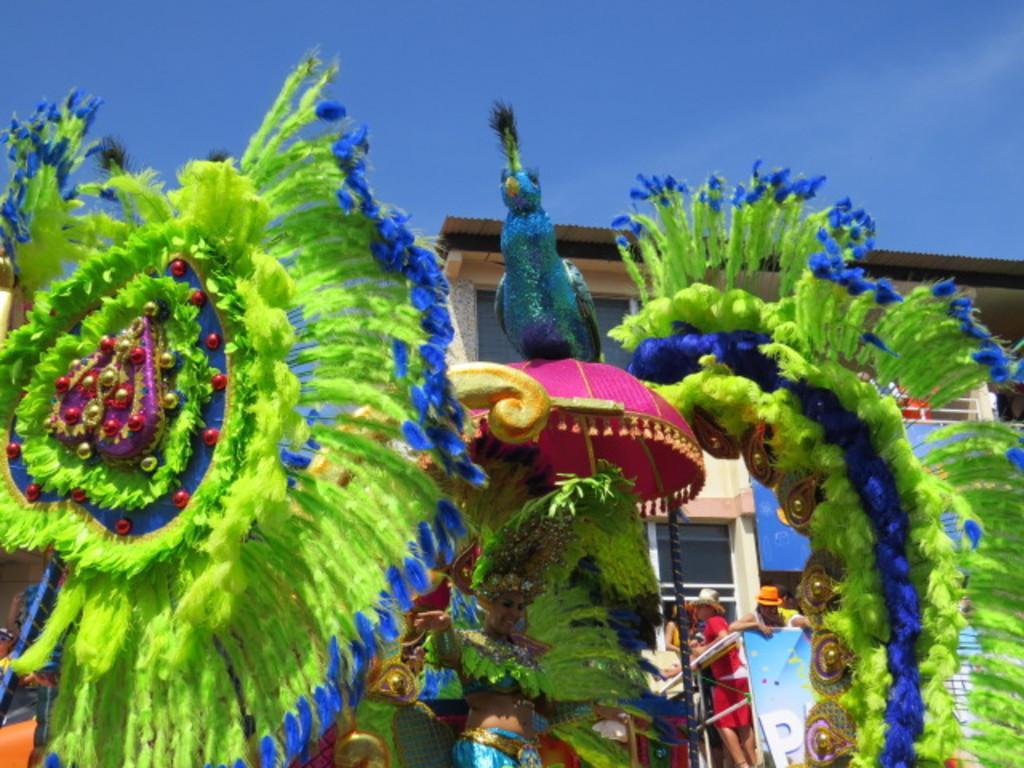Could you give a brief overview of what you see in this image? In this image there is a woman wearing a colorful dress, it looks like a carnival, behind the woman there is a building, in front of building there are persons, at the top there is the sky. 